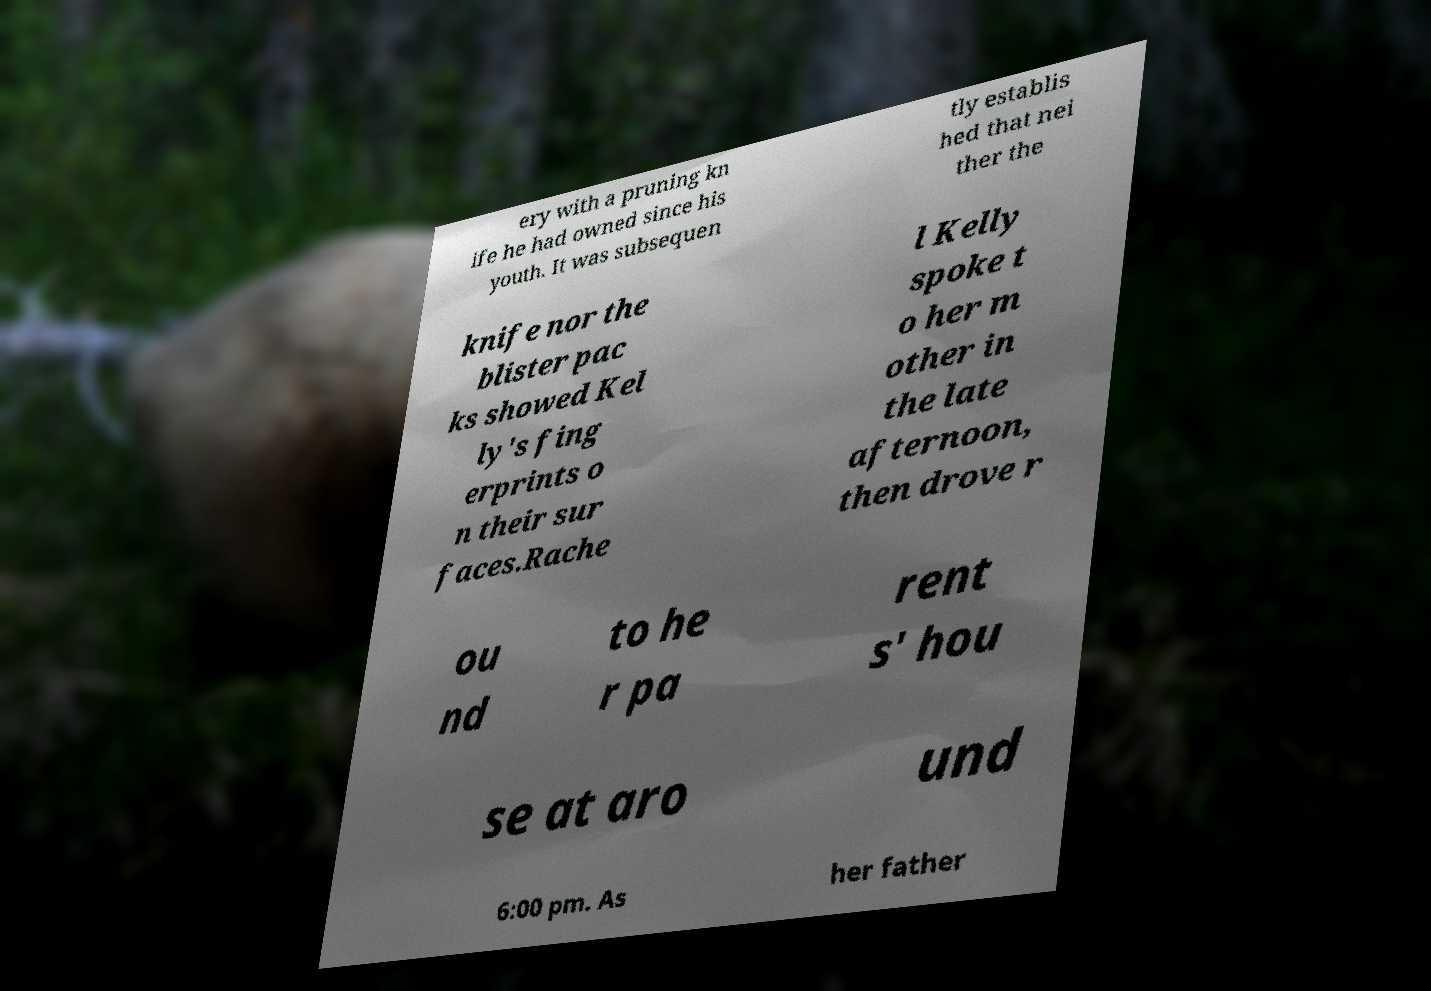Could you extract and type out the text from this image? ery with a pruning kn ife he had owned since his youth. It was subsequen tly establis hed that nei ther the knife nor the blister pac ks showed Kel ly's fing erprints o n their sur faces.Rache l Kelly spoke t o her m other in the late afternoon, then drove r ou nd to he r pa rent s' hou se at aro und 6:00 pm. As her father 